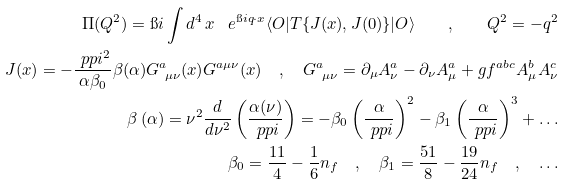<formula> <loc_0><loc_0><loc_500><loc_500>\Pi ( Q ^ { 2 } ) = \i i \int d ^ { 4 } \, x \, \ e ^ { \i i q \cdot x } \langle O | T \{ J ( x ) , J ( 0 ) \} | O \rangle \quad , \quad Q ^ { 2 } = - q ^ { 2 } \\ J ( x ) = - \frac { \ p p i ^ { 2 } } { \alpha \beta _ { 0 } } \beta ( \alpha ) G ^ { a } _ { \ \mu \nu } ( x ) G ^ { a \mu \nu } ( x ) \quad , \quad G ^ { a } _ { \ \mu \nu } = \partial _ { \mu } A ^ { a } _ { \nu } - \partial _ { \nu } A ^ { a } _ { \mu } + g f ^ { a b c } A ^ { b } _ { \mu } A ^ { c } _ { \nu } \\ \beta \left ( \alpha \right ) = \nu ^ { 2 } \frac { d } { d \nu ^ { 2 } } \left ( \frac { \alpha ( \nu ) } { \ p p i } \right ) = - \beta _ { 0 } \left ( \frac { \alpha } { \ p p i } \right ) ^ { 2 } - \beta _ { 1 } \left ( \frac { \alpha } { \ p p i } \right ) ^ { 3 } + \dots \\ \beta _ { 0 } = \frac { 1 1 } { 4 } - \frac { 1 } { 6 } n _ { f } \quad , \quad \beta _ { 1 } = \frac { 5 1 } { 8 } - \frac { 1 9 } { 2 4 } n _ { f } \quad , \quad \dots</formula> 